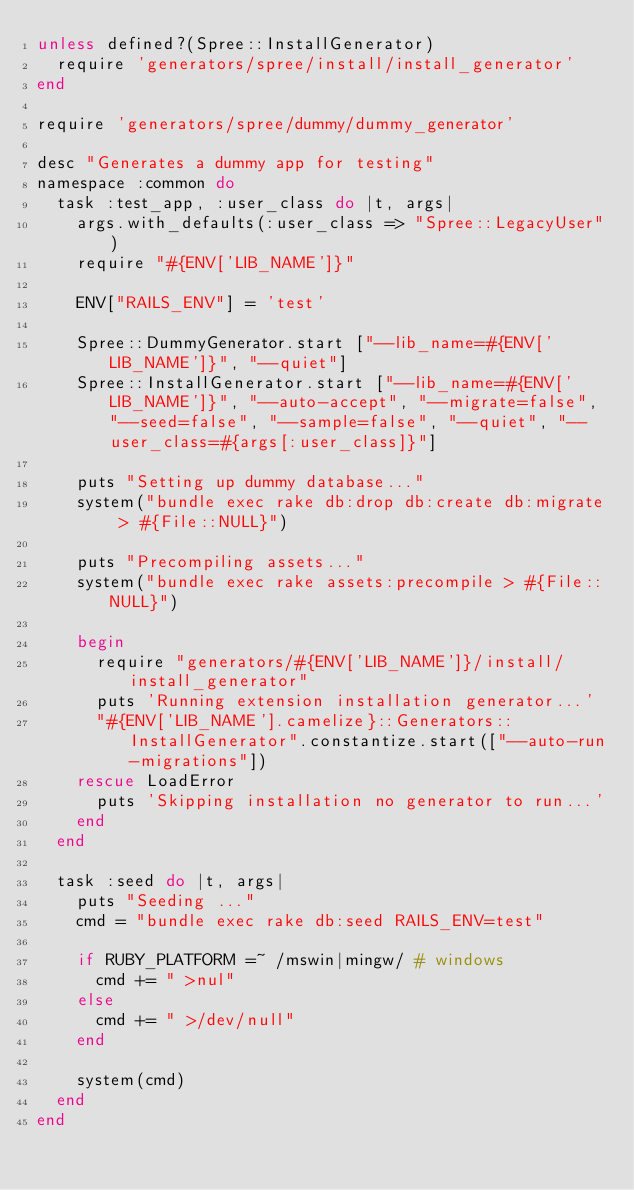Convert code to text. <code><loc_0><loc_0><loc_500><loc_500><_Ruby_>unless defined?(Spree::InstallGenerator)
  require 'generators/spree/install/install_generator'
end

require 'generators/spree/dummy/dummy_generator'

desc "Generates a dummy app for testing"
namespace :common do
  task :test_app, :user_class do |t, args|
    args.with_defaults(:user_class => "Spree::LegacyUser")
    require "#{ENV['LIB_NAME']}"

    ENV["RAILS_ENV"] = 'test'

    Spree::DummyGenerator.start ["--lib_name=#{ENV['LIB_NAME']}", "--quiet"]
    Spree::InstallGenerator.start ["--lib_name=#{ENV['LIB_NAME']}", "--auto-accept", "--migrate=false", "--seed=false", "--sample=false", "--quiet", "--user_class=#{args[:user_class]}"]

    puts "Setting up dummy database..."
    system("bundle exec rake db:drop db:create db:migrate > #{File::NULL}")

    puts "Precompiling assets..."
    system("bundle exec rake assets:precompile > #{File::NULL}")

    begin
      require "generators/#{ENV['LIB_NAME']}/install/install_generator"
      puts 'Running extension installation generator...'
      "#{ENV['LIB_NAME'].camelize}::Generators::InstallGenerator".constantize.start(["--auto-run-migrations"])
    rescue LoadError
      puts 'Skipping installation no generator to run...'
    end
  end

  task :seed do |t, args|
    puts "Seeding ..."
    cmd = "bundle exec rake db:seed RAILS_ENV=test"

    if RUBY_PLATFORM =~ /mswin|mingw/ # windows
      cmd += " >nul"
    else
      cmd += " >/dev/null"
    end

    system(cmd)
  end
end
</code> 